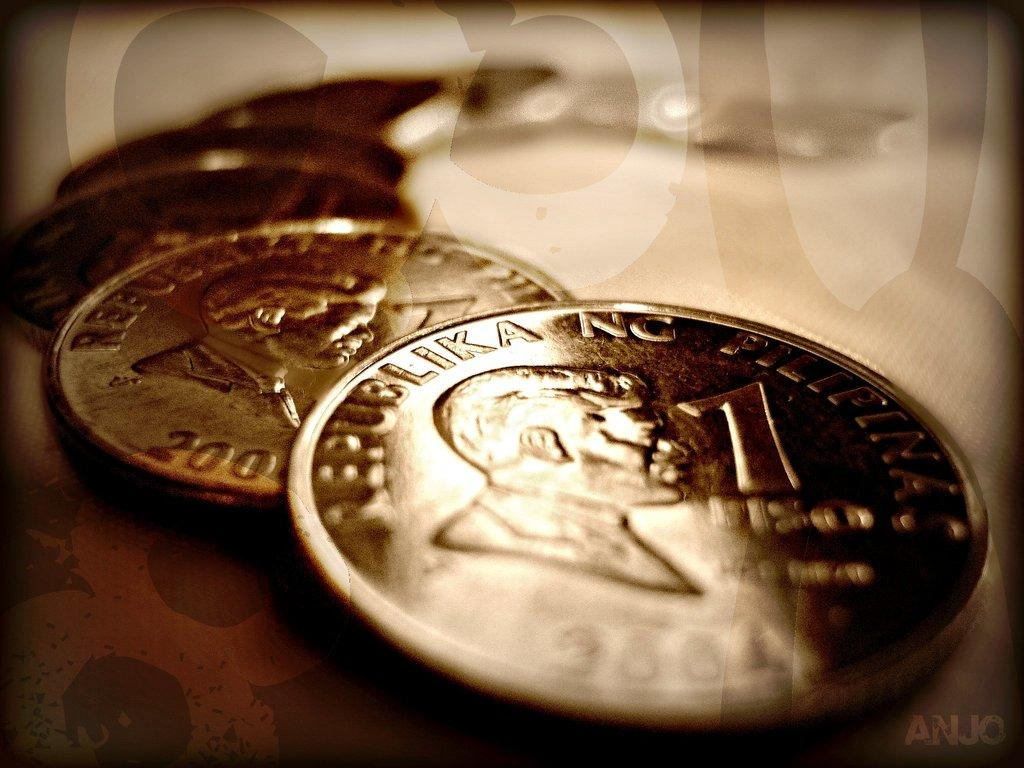<image>
Share a concise interpretation of the image provided. A series of coins have the number 1 next to a man's head. 